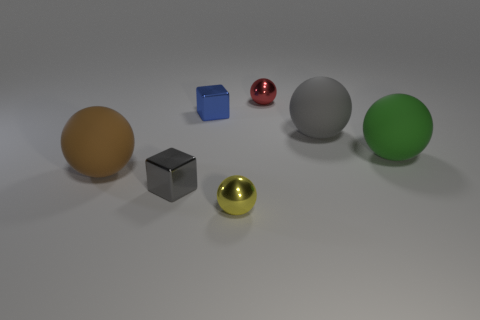Are there fewer tiny red metallic spheres than gray matte cylinders?
Give a very brief answer. No. What is the material of the blue object that is the same size as the gray shiny block?
Your answer should be compact. Metal. What number of things are objects or big yellow metal blocks?
Make the answer very short. 7. How many metal objects are both behind the tiny yellow metal ball and to the left of the tiny red thing?
Offer a terse response. 2. Are there fewer yellow shiny things to the right of the small red metallic ball than small yellow balls?
Provide a short and direct response. Yes. The gray object that is the same size as the brown object is what shape?
Your answer should be compact. Sphere. Does the brown thing have the same size as the red object?
Your response must be concise. No. How many things are tiny gray shiny objects or balls that are in front of the red metal thing?
Give a very brief answer. 5. Are there fewer green balls on the left side of the large brown matte object than tiny gray blocks on the right side of the tiny yellow metal object?
Your answer should be very brief. No. How many other objects are there of the same material as the green ball?
Make the answer very short. 2. 